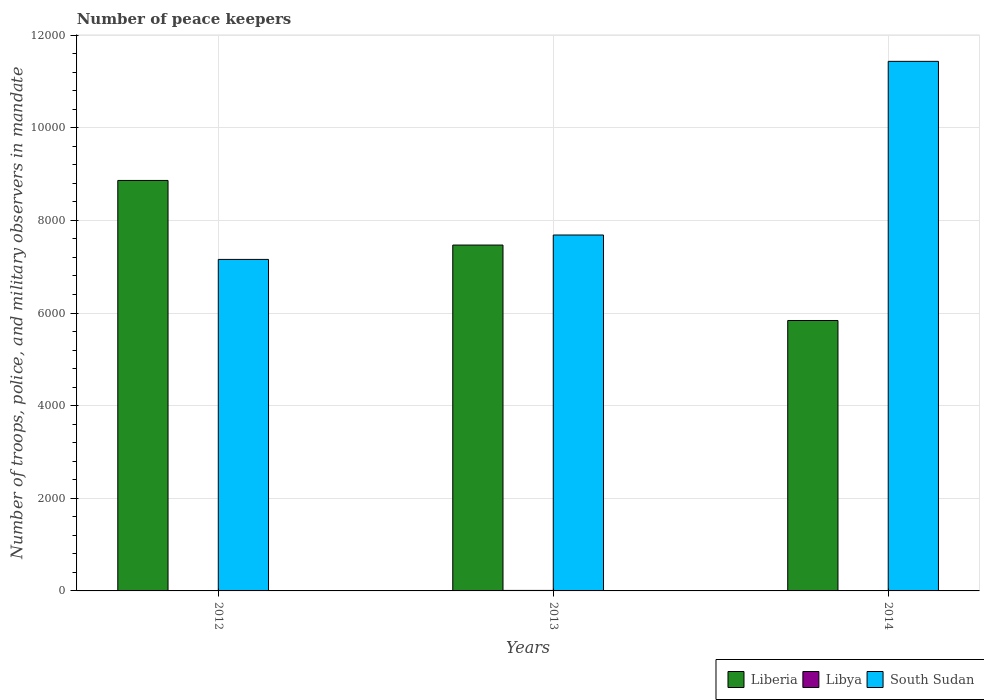How many different coloured bars are there?
Offer a terse response. 3. How many groups of bars are there?
Provide a succinct answer. 3. Are the number of bars on each tick of the X-axis equal?
Keep it short and to the point. Yes. What is the label of the 3rd group of bars from the left?
Your answer should be very brief. 2014. In how many cases, is the number of bars for a given year not equal to the number of legend labels?
Your response must be concise. 0. What is the number of peace keepers in in South Sudan in 2014?
Give a very brief answer. 1.14e+04. Across all years, what is the maximum number of peace keepers in in Liberia?
Provide a short and direct response. 8862. Across all years, what is the minimum number of peace keepers in in Liberia?
Ensure brevity in your answer.  5838. In which year was the number of peace keepers in in Libya minimum?
Make the answer very short. 2012. What is the total number of peace keepers in in South Sudan in the graph?
Your answer should be very brief. 2.63e+04. What is the difference between the number of peace keepers in in Liberia in 2013 and that in 2014?
Offer a very short reply. 1629. What is the difference between the number of peace keepers in in Libya in 2012 and the number of peace keepers in in South Sudan in 2013?
Your answer should be compact. -7682. What is the average number of peace keepers in in Liberia per year?
Provide a succinct answer. 7389. In the year 2012, what is the difference between the number of peace keepers in in Liberia and number of peace keepers in in South Sudan?
Give a very brief answer. 1705. In how many years, is the number of peace keepers in in Libya greater than 9600?
Offer a very short reply. 0. What is the ratio of the number of peace keepers in in Liberia in 2013 to that in 2014?
Provide a succinct answer. 1.28. Is the difference between the number of peace keepers in in Liberia in 2012 and 2013 greater than the difference between the number of peace keepers in in South Sudan in 2012 and 2013?
Provide a short and direct response. Yes. What is the difference between the highest and the lowest number of peace keepers in in South Sudan?
Make the answer very short. 4276. In how many years, is the number of peace keepers in in Liberia greater than the average number of peace keepers in in Liberia taken over all years?
Your response must be concise. 2. Is the sum of the number of peace keepers in in Liberia in 2012 and 2014 greater than the maximum number of peace keepers in in Libya across all years?
Ensure brevity in your answer.  Yes. What does the 1st bar from the left in 2012 represents?
Offer a very short reply. Liberia. What does the 3rd bar from the right in 2013 represents?
Your response must be concise. Liberia. How many years are there in the graph?
Ensure brevity in your answer.  3. What is the difference between two consecutive major ticks on the Y-axis?
Give a very brief answer. 2000. Does the graph contain grids?
Give a very brief answer. Yes. How are the legend labels stacked?
Ensure brevity in your answer.  Horizontal. What is the title of the graph?
Keep it short and to the point. Number of peace keepers. What is the label or title of the Y-axis?
Offer a very short reply. Number of troops, police, and military observers in mandate. What is the Number of troops, police, and military observers in mandate of Liberia in 2012?
Keep it short and to the point. 8862. What is the Number of troops, police, and military observers in mandate in South Sudan in 2012?
Offer a terse response. 7157. What is the Number of troops, police, and military observers in mandate of Liberia in 2013?
Make the answer very short. 7467. What is the Number of troops, police, and military observers in mandate of Libya in 2013?
Your answer should be very brief. 11. What is the Number of troops, police, and military observers in mandate in South Sudan in 2013?
Keep it short and to the point. 7684. What is the Number of troops, police, and military observers in mandate of Liberia in 2014?
Offer a terse response. 5838. What is the Number of troops, police, and military observers in mandate of Libya in 2014?
Offer a very short reply. 2. What is the Number of troops, police, and military observers in mandate in South Sudan in 2014?
Provide a succinct answer. 1.14e+04. Across all years, what is the maximum Number of troops, police, and military observers in mandate in Liberia?
Make the answer very short. 8862. Across all years, what is the maximum Number of troops, police, and military observers in mandate of Libya?
Make the answer very short. 11. Across all years, what is the maximum Number of troops, police, and military observers in mandate in South Sudan?
Your answer should be very brief. 1.14e+04. Across all years, what is the minimum Number of troops, police, and military observers in mandate in Liberia?
Your answer should be very brief. 5838. Across all years, what is the minimum Number of troops, police, and military observers in mandate of South Sudan?
Your answer should be very brief. 7157. What is the total Number of troops, police, and military observers in mandate in Liberia in the graph?
Your answer should be compact. 2.22e+04. What is the total Number of troops, police, and military observers in mandate in South Sudan in the graph?
Ensure brevity in your answer.  2.63e+04. What is the difference between the Number of troops, police, and military observers in mandate of Liberia in 2012 and that in 2013?
Provide a succinct answer. 1395. What is the difference between the Number of troops, police, and military observers in mandate in Libya in 2012 and that in 2013?
Provide a succinct answer. -9. What is the difference between the Number of troops, police, and military observers in mandate in South Sudan in 2012 and that in 2013?
Provide a short and direct response. -527. What is the difference between the Number of troops, police, and military observers in mandate in Liberia in 2012 and that in 2014?
Provide a succinct answer. 3024. What is the difference between the Number of troops, police, and military observers in mandate of Libya in 2012 and that in 2014?
Your answer should be compact. 0. What is the difference between the Number of troops, police, and military observers in mandate of South Sudan in 2012 and that in 2014?
Your answer should be very brief. -4276. What is the difference between the Number of troops, police, and military observers in mandate in Liberia in 2013 and that in 2014?
Make the answer very short. 1629. What is the difference between the Number of troops, police, and military observers in mandate of South Sudan in 2013 and that in 2014?
Make the answer very short. -3749. What is the difference between the Number of troops, police, and military observers in mandate of Liberia in 2012 and the Number of troops, police, and military observers in mandate of Libya in 2013?
Your answer should be very brief. 8851. What is the difference between the Number of troops, police, and military observers in mandate of Liberia in 2012 and the Number of troops, police, and military observers in mandate of South Sudan in 2013?
Ensure brevity in your answer.  1178. What is the difference between the Number of troops, police, and military observers in mandate in Libya in 2012 and the Number of troops, police, and military observers in mandate in South Sudan in 2013?
Your answer should be compact. -7682. What is the difference between the Number of troops, police, and military observers in mandate in Liberia in 2012 and the Number of troops, police, and military observers in mandate in Libya in 2014?
Provide a short and direct response. 8860. What is the difference between the Number of troops, police, and military observers in mandate of Liberia in 2012 and the Number of troops, police, and military observers in mandate of South Sudan in 2014?
Keep it short and to the point. -2571. What is the difference between the Number of troops, police, and military observers in mandate in Libya in 2012 and the Number of troops, police, and military observers in mandate in South Sudan in 2014?
Offer a very short reply. -1.14e+04. What is the difference between the Number of troops, police, and military observers in mandate in Liberia in 2013 and the Number of troops, police, and military observers in mandate in Libya in 2014?
Offer a terse response. 7465. What is the difference between the Number of troops, police, and military observers in mandate in Liberia in 2013 and the Number of troops, police, and military observers in mandate in South Sudan in 2014?
Your answer should be compact. -3966. What is the difference between the Number of troops, police, and military observers in mandate of Libya in 2013 and the Number of troops, police, and military observers in mandate of South Sudan in 2014?
Provide a short and direct response. -1.14e+04. What is the average Number of troops, police, and military observers in mandate of Liberia per year?
Your answer should be compact. 7389. What is the average Number of troops, police, and military observers in mandate of South Sudan per year?
Provide a succinct answer. 8758. In the year 2012, what is the difference between the Number of troops, police, and military observers in mandate of Liberia and Number of troops, police, and military observers in mandate of Libya?
Make the answer very short. 8860. In the year 2012, what is the difference between the Number of troops, police, and military observers in mandate of Liberia and Number of troops, police, and military observers in mandate of South Sudan?
Your answer should be compact. 1705. In the year 2012, what is the difference between the Number of troops, police, and military observers in mandate of Libya and Number of troops, police, and military observers in mandate of South Sudan?
Provide a short and direct response. -7155. In the year 2013, what is the difference between the Number of troops, police, and military observers in mandate in Liberia and Number of troops, police, and military observers in mandate in Libya?
Your response must be concise. 7456. In the year 2013, what is the difference between the Number of troops, police, and military observers in mandate of Liberia and Number of troops, police, and military observers in mandate of South Sudan?
Ensure brevity in your answer.  -217. In the year 2013, what is the difference between the Number of troops, police, and military observers in mandate in Libya and Number of troops, police, and military observers in mandate in South Sudan?
Keep it short and to the point. -7673. In the year 2014, what is the difference between the Number of troops, police, and military observers in mandate in Liberia and Number of troops, police, and military observers in mandate in Libya?
Your response must be concise. 5836. In the year 2014, what is the difference between the Number of troops, police, and military observers in mandate of Liberia and Number of troops, police, and military observers in mandate of South Sudan?
Your answer should be compact. -5595. In the year 2014, what is the difference between the Number of troops, police, and military observers in mandate of Libya and Number of troops, police, and military observers in mandate of South Sudan?
Ensure brevity in your answer.  -1.14e+04. What is the ratio of the Number of troops, police, and military observers in mandate of Liberia in 2012 to that in 2013?
Provide a succinct answer. 1.19. What is the ratio of the Number of troops, police, and military observers in mandate of Libya in 2012 to that in 2013?
Offer a very short reply. 0.18. What is the ratio of the Number of troops, police, and military observers in mandate in South Sudan in 2012 to that in 2013?
Ensure brevity in your answer.  0.93. What is the ratio of the Number of troops, police, and military observers in mandate of Liberia in 2012 to that in 2014?
Your answer should be very brief. 1.52. What is the ratio of the Number of troops, police, and military observers in mandate of Libya in 2012 to that in 2014?
Keep it short and to the point. 1. What is the ratio of the Number of troops, police, and military observers in mandate of South Sudan in 2012 to that in 2014?
Provide a succinct answer. 0.63. What is the ratio of the Number of troops, police, and military observers in mandate in Liberia in 2013 to that in 2014?
Give a very brief answer. 1.28. What is the ratio of the Number of troops, police, and military observers in mandate in South Sudan in 2013 to that in 2014?
Offer a very short reply. 0.67. What is the difference between the highest and the second highest Number of troops, police, and military observers in mandate of Liberia?
Offer a terse response. 1395. What is the difference between the highest and the second highest Number of troops, police, and military observers in mandate in South Sudan?
Provide a succinct answer. 3749. What is the difference between the highest and the lowest Number of troops, police, and military observers in mandate in Liberia?
Give a very brief answer. 3024. What is the difference between the highest and the lowest Number of troops, police, and military observers in mandate in South Sudan?
Provide a short and direct response. 4276. 